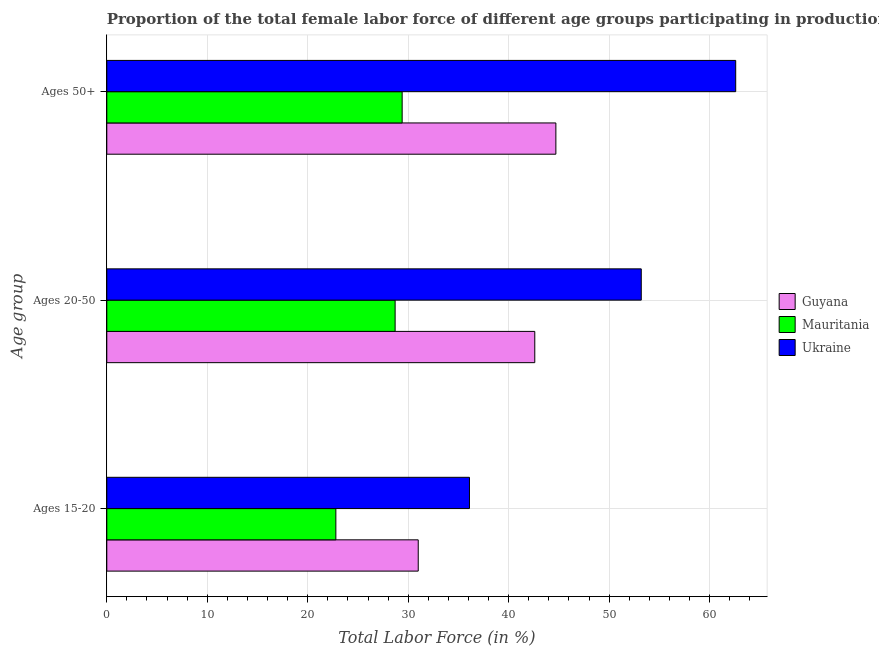Are the number of bars per tick equal to the number of legend labels?
Provide a short and direct response. Yes. Are the number of bars on each tick of the Y-axis equal?
Your response must be concise. Yes. What is the label of the 2nd group of bars from the top?
Your response must be concise. Ages 20-50. What is the percentage of female labor force above age 50 in Ukraine?
Your answer should be very brief. 62.6. Across all countries, what is the maximum percentage of female labor force within the age group 15-20?
Your answer should be compact. 36.1. Across all countries, what is the minimum percentage of female labor force within the age group 15-20?
Offer a terse response. 22.8. In which country was the percentage of female labor force within the age group 15-20 maximum?
Offer a very short reply. Ukraine. In which country was the percentage of female labor force within the age group 15-20 minimum?
Your answer should be very brief. Mauritania. What is the total percentage of female labor force above age 50 in the graph?
Your response must be concise. 136.7. What is the difference between the percentage of female labor force within the age group 20-50 in Ukraine and that in Mauritania?
Offer a terse response. 24.5. What is the difference between the percentage of female labor force within the age group 15-20 in Mauritania and the percentage of female labor force within the age group 20-50 in Ukraine?
Your response must be concise. -30.4. What is the average percentage of female labor force within the age group 15-20 per country?
Your answer should be compact. 29.97. What is the difference between the percentage of female labor force above age 50 and percentage of female labor force within the age group 20-50 in Mauritania?
Ensure brevity in your answer.  0.7. In how many countries, is the percentage of female labor force within the age group 15-20 greater than 56 %?
Provide a short and direct response. 0. What is the ratio of the percentage of female labor force within the age group 20-50 in Ukraine to that in Guyana?
Give a very brief answer. 1.25. Is the difference between the percentage of female labor force within the age group 20-50 in Ukraine and Guyana greater than the difference between the percentage of female labor force within the age group 15-20 in Ukraine and Guyana?
Keep it short and to the point. Yes. What is the difference between the highest and the second highest percentage of female labor force above age 50?
Provide a short and direct response. 17.9. What is the difference between the highest and the lowest percentage of female labor force above age 50?
Provide a short and direct response. 33.2. What does the 3rd bar from the top in Ages 20-50 represents?
Your answer should be compact. Guyana. What does the 3rd bar from the bottom in Ages 50+ represents?
Your answer should be compact. Ukraine. Is it the case that in every country, the sum of the percentage of female labor force within the age group 15-20 and percentage of female labor force within the age group 20-50 is greater than the percentage of female labor force above age 50?
Your answer should be very brief. Yes. Are all the bars in the graph horizontal?
Make the answer very short. Yes. Are the values on the major ticks of X-axis written in scientific E-notation?
Provide a short and direct response. No. What is the title of the graph?
Provide a succinct answer. Proportion of the total female labor force of different age groups participating in production in 2013. What is the label or title of the X-axis?
Your answer should be very brief. Total Labor Force (in %). What is the label or title of the Y-axis?
Offer a very short reply. Age group. What is the Total Labor Force (in %) in Mauritania in Ages 15-20?
Offer a terse response. 22.8. What is the Total Labor Force (in %) in Ukraine in Ages 15-20?
Offer a very short reply. 36.1. What is the Total Labor Force (in %) in Guyana in Ages 20-50?
Your response must be concise. 42.6. What is the Total Labor Force (in %) in Mauritania in Ages 20-50?
Your answer should be compact. 28.7. What is the Total Labor Force (in %) in Ukraine in Ages 20-50?
Your answer should be compact. 53.2. What is the Total Labor Force (in %) of Guyana in Ages 50+?
Ensure brevity in your answer.  44.7. What is the Total Labor Force (in %) of Mauritania in Ages 50+?
Your answer should be compact. 29.4. What is the Total Labor Force (in %) in Ukraine in Ages 50+?
Make the answer very short. 62.6. Across all Age group, what is the maximum Total Labor Force (in %) in Guyana?
Offer a terse response. 44.7. Across all Age group, what is the maximum Total Labor Force (in %) in Mauritania?
Your response must be concise. 29.4. Across all Age group, what is the maximum Total Labor Force (in %) of Ukraine?
Ensure brevity in your answer.  62.6. Across all Age group, what is the minimum Total Labor Force (in %) in Guyana?
Keep it short and to the point. 31. Across all Age group, what is the minimum Total Labor Force (in %) of Mauritania?
Offer a terse response. 22.8. Across all Age group, what is the minimum Total Labor Force (in %) in Ukraine?
Your answer should be compact. 36.1. What is the total Total Labor Force (in %) of Guyana in the graph?
Give a very brief answer. 118.3. What is the total Total Labor Force (in %) of Mauritania in the graph?
Give a very brief answer. 80.9. What is the total Total Labor Force (in %) of Ukraine in the graph?
Offer a terse response. 151.9. What is the difference between the Total Labor Force (in %) of Mauritania in Ages 15-20 and that in Ages 20-50?
Provide a succinct answer. -5.9. What is the difference between the Total Labor Force (in %) in Ukraine in Ages 15-20 and that in Ages 20-50?
Provide a short and direct response. -17.1. What is the difference between the Total Labor Force (in %) in Guyana in Ages 15-20 and that in Ages 50+?
Make the answer very short. -13.7. What is the difference between the Total Labor Force (in %) of Ukraine in Ages 15-20 and that in Ages 50+?
Your answer should be compact. -26.5. What is the difference between the Total Labor Force (in %) in Mauritania in Ages 20-50 and that in Ages 50+?
Your answer should be very brief. -0.7. What is the difference between the Total Labor Force (in %) in Ukraine in Ages 20-50 and that in Ages 50+?
Give a very brief answer. -9.4. What is the difference between the Total Labor Force (in %) in Guyana in Ages 15-20 and the Total Labor Force (in %) in Ukraine in Ages 20-50?
Give a very brief answer. -22.2. What is the difference between the Total Labor Force (in %) in Mauritania in Ages 15-20 and the Total Labor Force (in %) in Ukraine in Ages 20-50?
Give a very brief answer. -30.4. What is the difference between the Total Labor Force (in %) of Guyana in Ages 15-20 and the Total Labor Force (in %) of Mauritania in Ages 50+?
Make the answer very short. 1.6. What is the difference between the Total Labor Force (in %) in Guyana in Ages 15-20 and the Total Labor Force (in %) in Ukraine in Ages 50+?
Offer a terse response. -31.6. What is the difference between the Total Labor Force (in %) in Mauritania in Ages 15-20 and the Total Labor Force (in %) in Ukraine in Ages 50+?
Offer a very short reply. -39.8. What is the difference between the Total Labor Force (in %) of Guyana in Ages 20-50 and the Total Labor Force (in %) of Ukraine in Ages 50+?
Provide a short and direct response. -20. What is the difference between the Total Labor Force (in %) of Mauritania in Ages 20-50 and the Total Labor Force (in %) of Ukraine in Ages 50+?
Ensure brevity in your answer.  -33.9. What is the average Total Labor Force (in %) of Guyana per Age group?
Your answer should be very brief. 39.43. What is the average Total Labor Force (in %) in Mauritania per Age group?
Give a very brief answer. 26.97. What is the average Total Labor Force (in %) in Ukraine per Age group?
Offer a terse response. 50.63. What is the difference between the Total Labor Force (in %) in Guyana and Total Labor Force (in %) in Mauritania in Ages 15-20?
Provide a short and direct response. 8.2. What is the difference between the Total Labor Force (in %) in Guyana and Total Labor Force (in %) in Ukraine in Ages 15-20?
Provide a short and direct response. -5.1. What is the difference between the Total Labor Force (in %) of Guyana and Total Labor Force (in %) of Mauritania in Ages 20-50?
Your answer should be compact. 13.9. What is the difference between the Total Labor Force (in %) of Guyana and Total Labor Force (in %) of Ukraine in Ages 20-50?
Your response must be concise. -10.6. What is the difference between the Total Labor Force (in %) in Mauritania and Total Labor Force (in %) in Ukraine in Ages 20-50?
Your answer should be compact. -24.5. What is the difference between the Total Labor Force (in %) in Guyana and Total Labor Force (in %) in Mauritania in Ages 50+?
Make the answer very short. 15.3. What is the difference between the Total Labor Force (in %) in Guyana and Total Labor Force (in %) in Ukraine in Ages 50+?
Offer a terse response. -17.9. What is the difference between the Total Labor Force (in %) in Mauritania and Total Labor Force (in %) in Ukraine in Ages 50+?
Provide a short and direct response. -33.2. What is the ratio of the Total Labor Force (in %) in Guyana in Ages 15-20 to that in Ages 20-50?
Ensure brevity in your answer.  0.73. What is the ratio of the Total Labor Force (in %) in Mauritania in Ages 15-20 to that in Ages 20-50?
Offer a very short reply. 0.79. What is the ratio of the Total Labor Force (in %) in Ukraine in Ages 15-20 to that in Ages 20-50?
Keep it short and to the point. 0.68. What is the ratio of the Total Labor Force (in %) in Guyana in Ages 15-20 to that in Ages 50+?
Your answer should be compact. 0.69. What is the ratio of the Total Labor Force (in %) of Mauritania in Ages 15-20 to that in Ages 50+?
Offer a terse response. 0.78. What is the ratio of the Total Labor Force (in %) of Ukraine in Ages 15-20 to that in Ages 50+?
Offer a terse response. 0.58. What is the ratio of the Total Labor Force (in %) in Guyana in Ages 20-50 to that in Ages 50+?
Provide a short and direct response. 0.95. What is the ratio of the Total Labor Force (in %) in Mauritania in Ages 20-50 to that in Ages 50+?
Keep it short and to the point. 0.98. What is the ratio of the Total Labor Force (in %) in Ukraine in Ages 20-50 to that in Ages 50+?
Provide a succinct answer. 0.85. What is the difference between the highest and the second highest Total Labor Force (in %) in Guyana?
Ensure brevity in your answer.  2.1. What is the difference between the highest and the lowest Total Labor Force (in %) in Mauritania?
Offer a terse response. 6.6. What is the difference between the highest and the lowest Total Labor Force (in %) of Ukraine?
Provide a short and direct response. 26.5. 